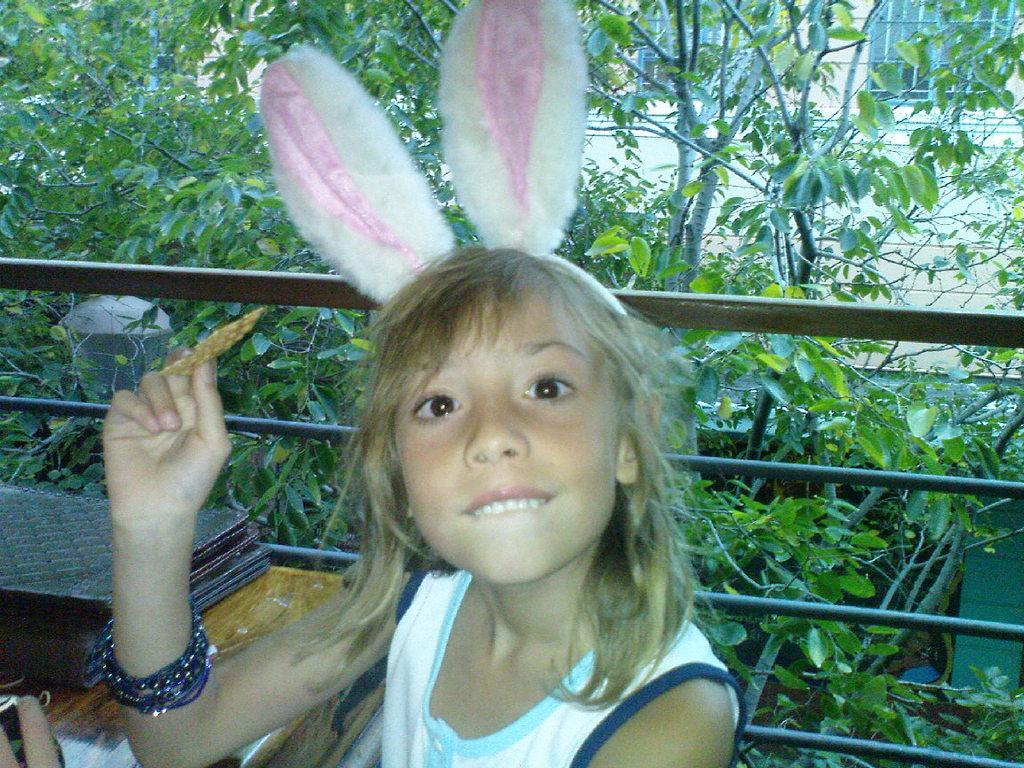What is the girl holding in the image? There is a girl holding an object in the image. What is on the table in the image? There are cards and other objects on the table in the image. What can be seen in the background of the image? There is a fence, trees, windows, and a building in the background of the image. What type of wood is the girl holding in the image? There is no mention of wood in the image. 